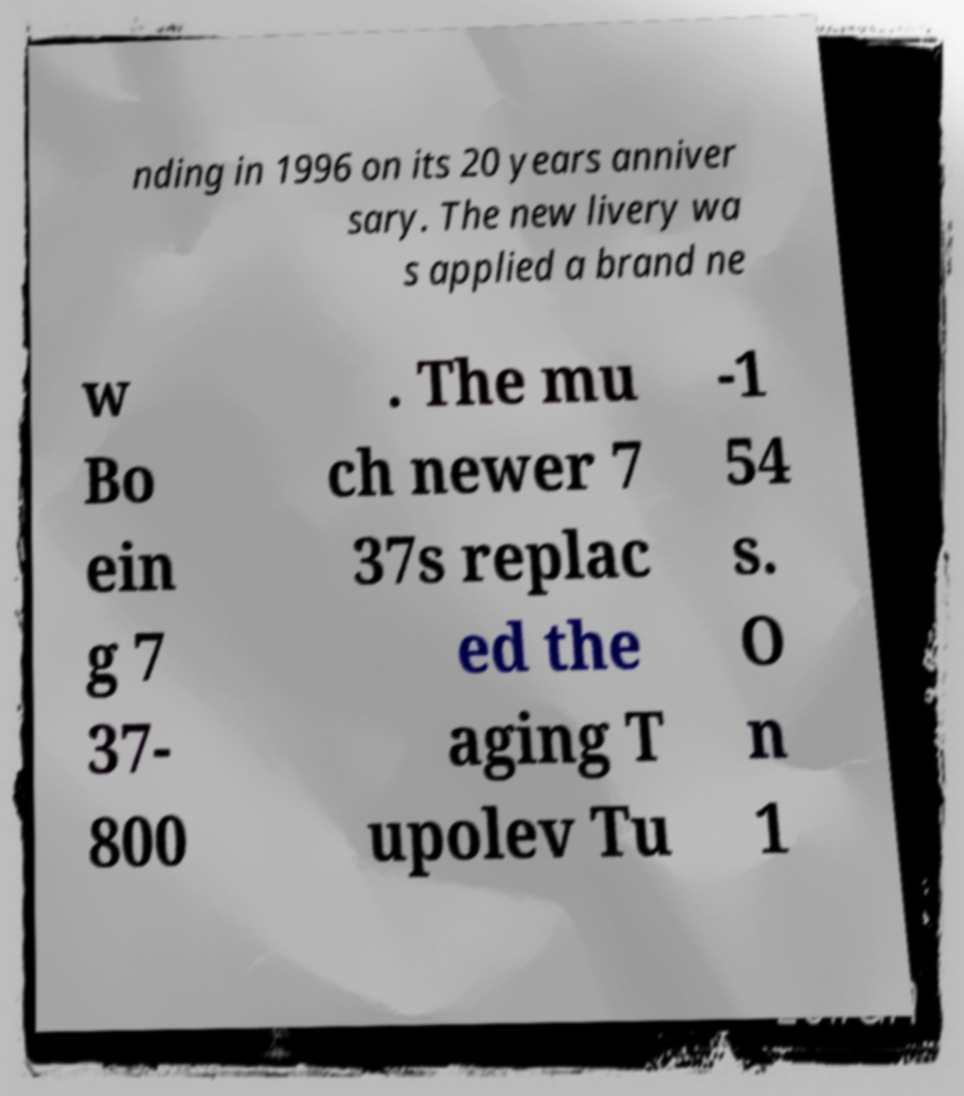Could you assist in decoding the text presented in this image and type it out clearly? nding in 1996 on its 20 years anniver sary. The new livery wa s applied a brand ne w Bo ein g 7 37- 800 . The mu ch newer 7 37s replac ed the aging T upolev Tu -1 54 s. O n 1 